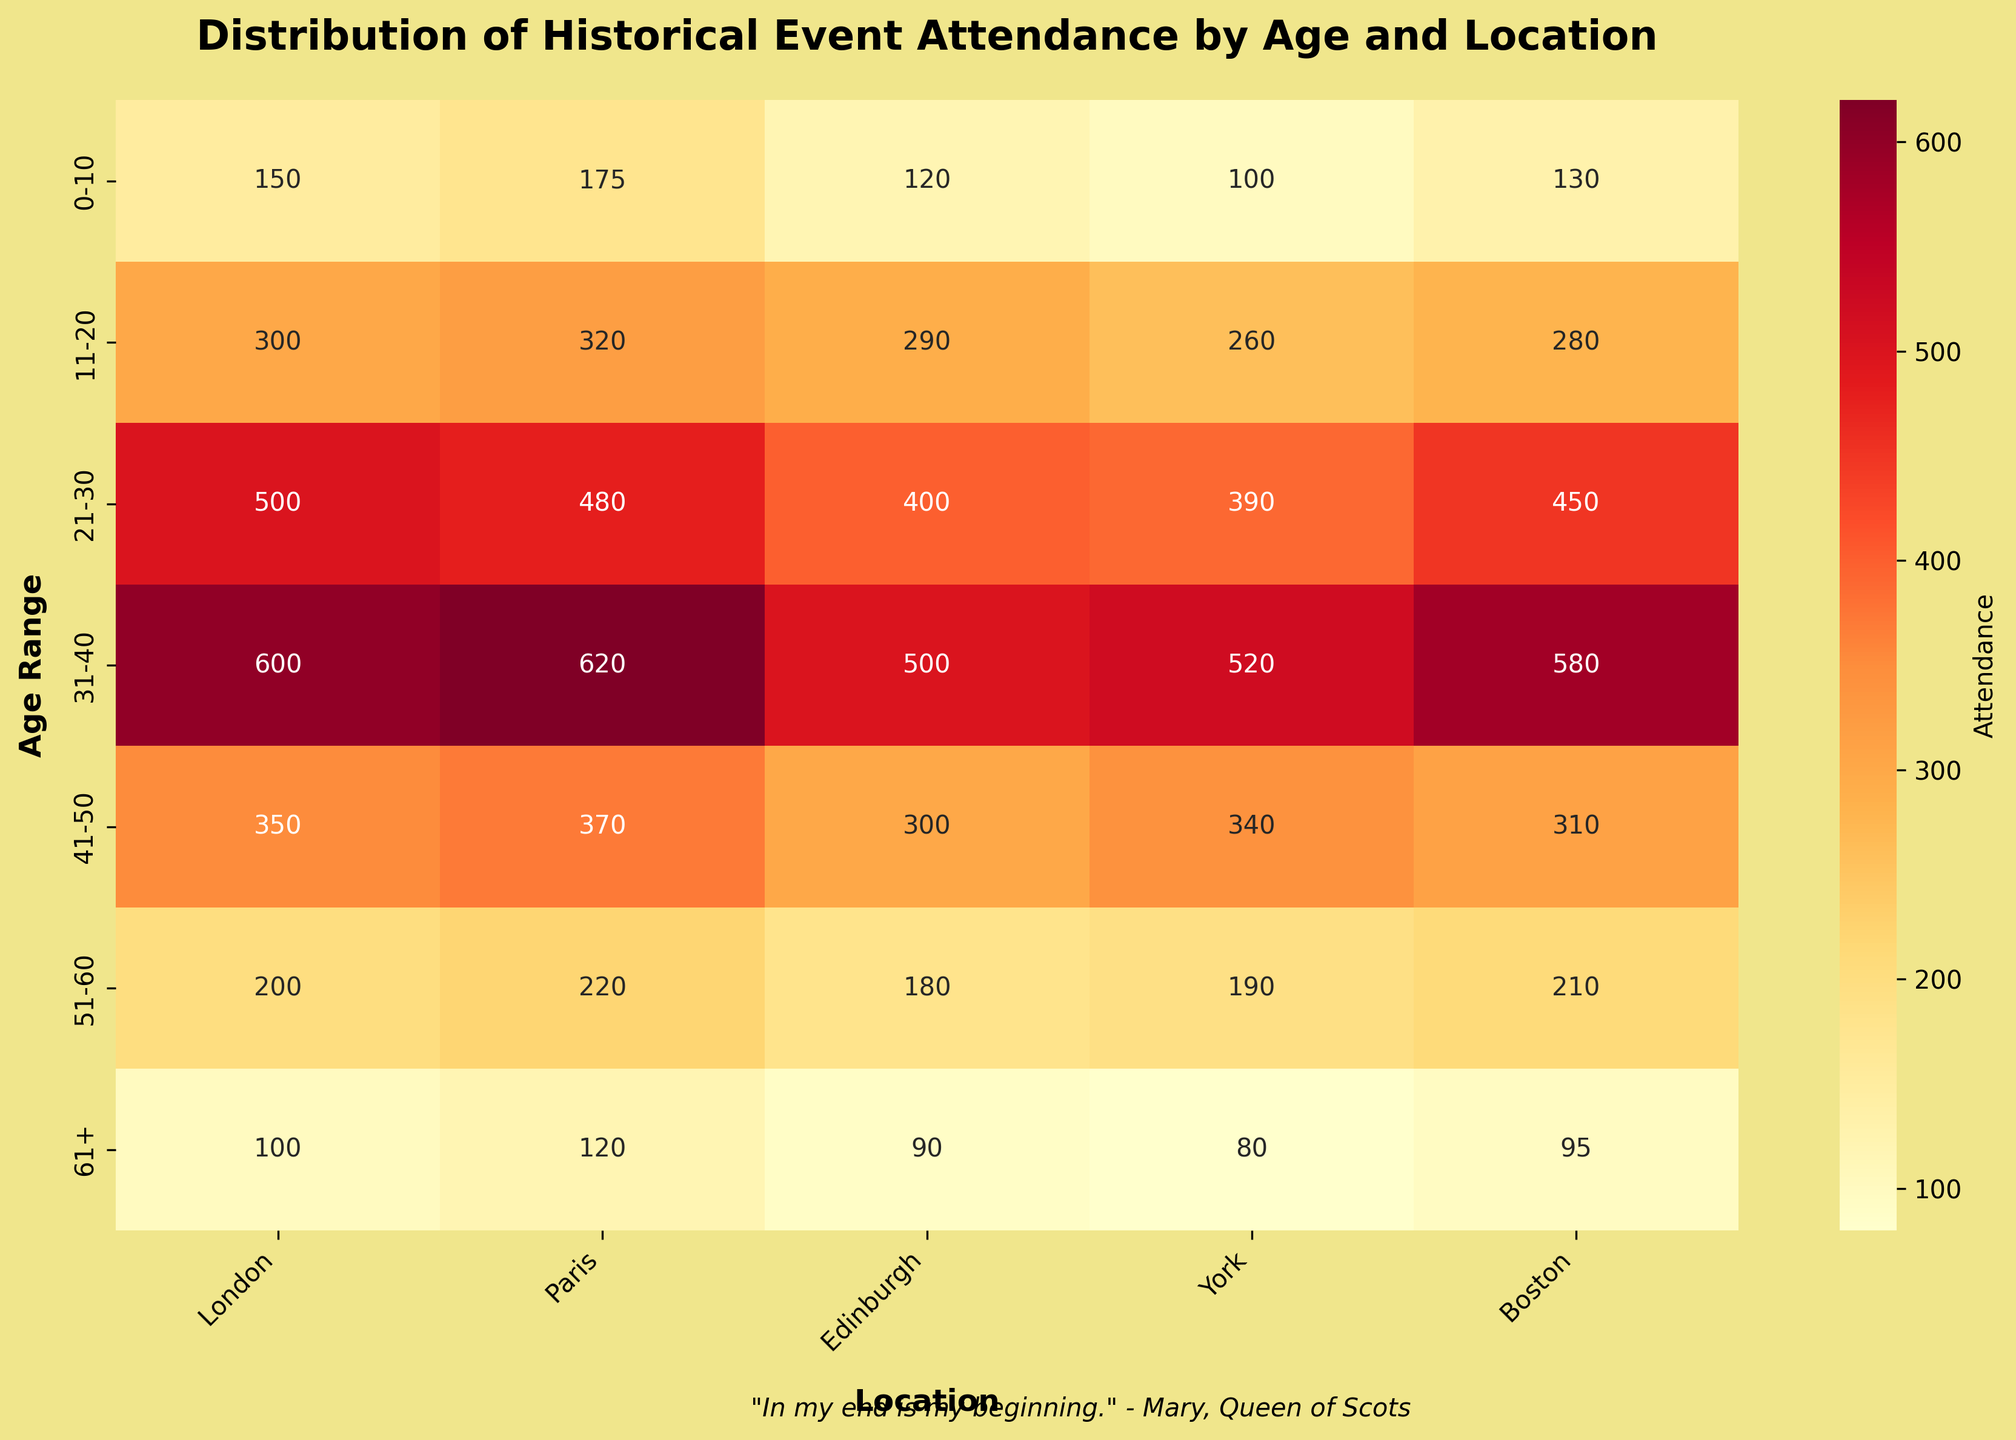What is the title of the heatmap? The title is usually found at the top of the heatmap. It gives a quick insight into what the plot is about.
Answer: Distribution of Historical Event Attendance by Age and Location Which location has the highest attendance for the age range 21-30? Locate the row for age range 21-30 and identify the largest value across the columns representing locations.
Answer: London What is the total attendance for the age range 31-40? Add up all the attendance numbers in the row corresponding to the age range 31-40 (600 + 620 + 500 + 520 + 580).
Answer: 2820 How does the attendance in Paris compare to London for the age range 51-60? Look at the row for age range 51-60 and compare the numbers in the Paris and London columns.
Answer: Paris has 20 more attendees than London (220 vs. 200) What is the average attendance across all locations for the age range 0-10? Add the attendance numbers for all locations in the 0-10 age range and divide by the number of locations (150 + 175 + 120 + 100 + 130) / 5.
Answer: 135 Which age range has the least attendance in York? Identify the smallest number in the York column by comparing all rows.
Answer: 61+ For the age range 41-50, which locations have attendance greater than 300? Check the values in the 41-50 row and note locations with attendance above 300.
Answer: London, Paris, York What is the combined attendance of all age ranges in Boston? Sum the values in the Boston column (130 + 280 + 450 + 580 + 310 + 210 + 95).
Answer: 2055 Is there any age range with attendance below 100 for all locations? Inspect each row to see if there is any row where all the values across locations are less than 100.
Answer: No What is unique about the background color of the plot? Check the visual features of the heatmap, specifically the background area around the plot.
Answer: It has a Khaki background 